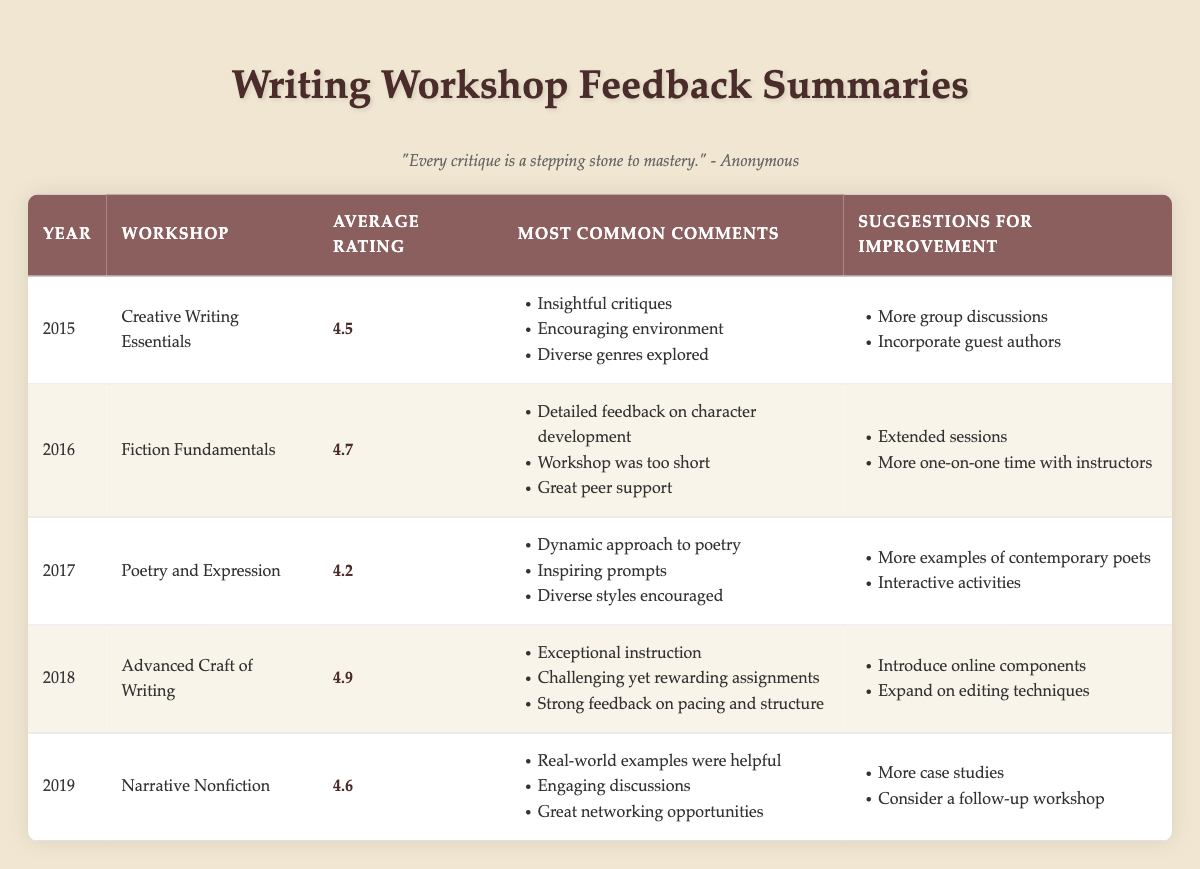What was the average rating of the workshop held in 2018? The average rating for the workshop "Advanced Craft of Writing" held in 2018 is listed directly in the table under that year. It shows an average rating of 4.9.
Answer: 4.9 Which workshop received the lowest average rating? To find the lowest average rating, we compare the average ratings of all workshops provided in the table. The ratings are 4.5, 4.7, 4.2, 4.9, and 4.6, respectively. The lowest is 4.2 for "Poetry and Expression" in 2017.
Answer: Poetry and Expression Did the workshop "Fiction Fundamentals" have any suggestions for improvement related to time management? Looking at the suggestions for "Fiction Fundamentals" in 2016, we see the demands for "Extended sessions" and "More one-on-one time with instructors." Both pertain to time management concerns.
Answer: Yes What is the average rating of workshops from 2015 to 2019? To compute the average rating from 2015 to 2019, we sum all average ratings: 4.5 + 4.7 + 4.2 + 4.9 + 4.6 = 24.9. Then we divide by the number of workshops (5): 24.9/5 = 4.98.
Answer: 4.98 Which year had the workshop with the most positive comments and the highest average rating? From the table, "Advanced Craft of Writing" in 2018 had the highest average rating of 4.9 and was noted for "Exceptional instruction," "Challenging yet rewarding assignments," and "Strong feedback on pacing and structure." 2018 thus had the most positive feedback overall.
Answer: 2018 